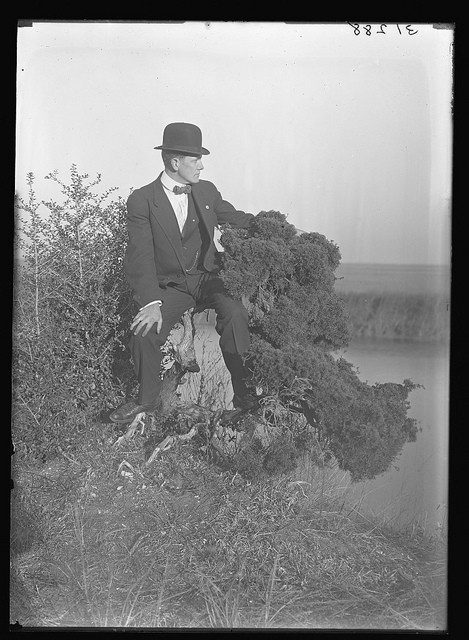Extract all visible text content from this image. 88213 